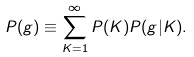<formula> <loc_0><loc_0><loc_500><loc_500>P ( g ) \equiv \sum _ { K = 1 } ^ { \infty } P ( K ) P ( g | K ) .</formula> 